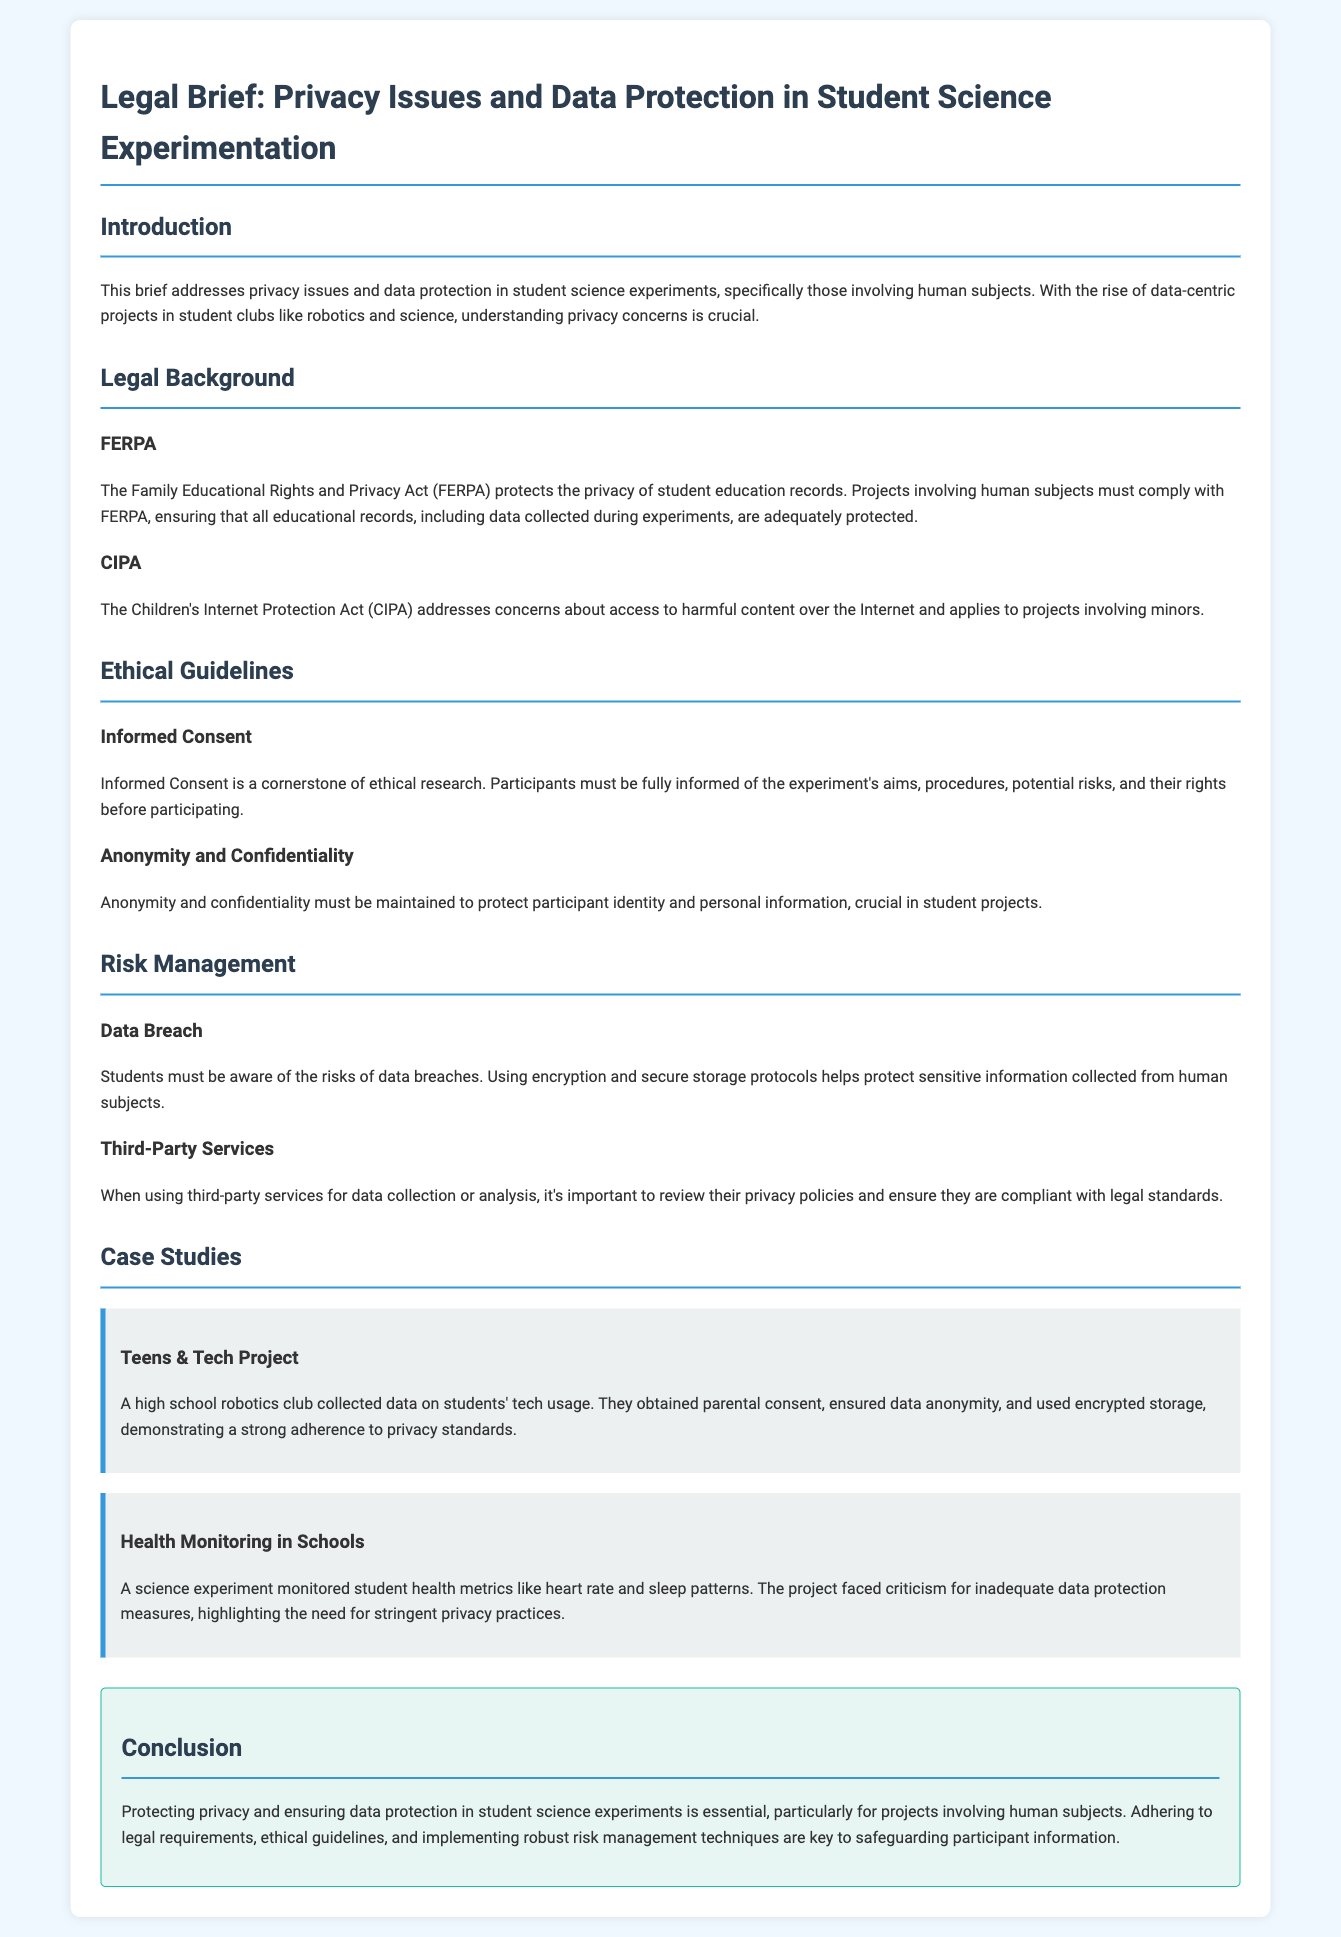What does FERPA protect? FERPA protects the privacy of student education records, which includes data collected during experiments.
Answer: Privacy of student education records What is a requirement for informed consent? Informed consent requires that participants must be fully informed of the experiment's aims, procedures, potential risks, and their rights before participating.
Answer: Full information What must students ensure when using third-party services? Students must review third-party services' privacy policies to ensure they are compliant with legal standards.
Answer: Compliance with legal standards What was a key aspect of the Teens & Tech Project? The Teens & Tech Project demonstrated a strong adherence to privacy standards through parental consent, data anonymity, and encrypted storage.
Answer: Strong adherence to privacy standards Which act addresses concerns about access to harmful content over the Internet? The Children's Internet Protection Act (CIPA) addresses concerns about access to harmful content over the Internet.
Answer: Children's Internet Protection Act (CIPA) 